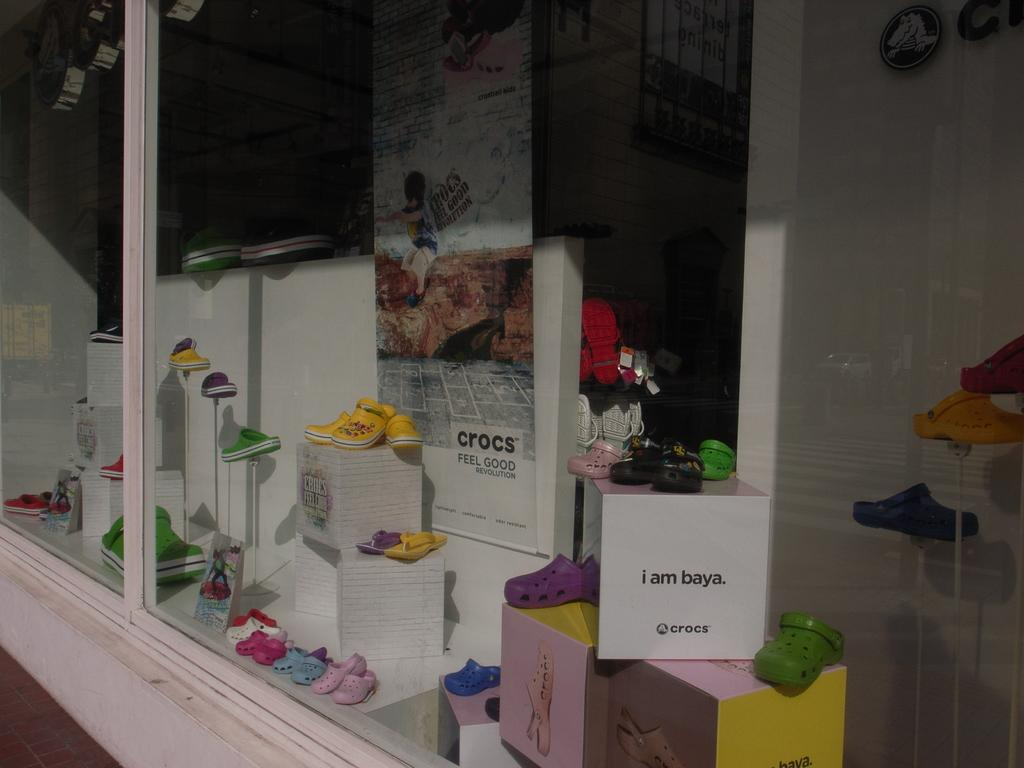<image>
Provide a brief description of the given image. store window display showing different crocs including one called baya 